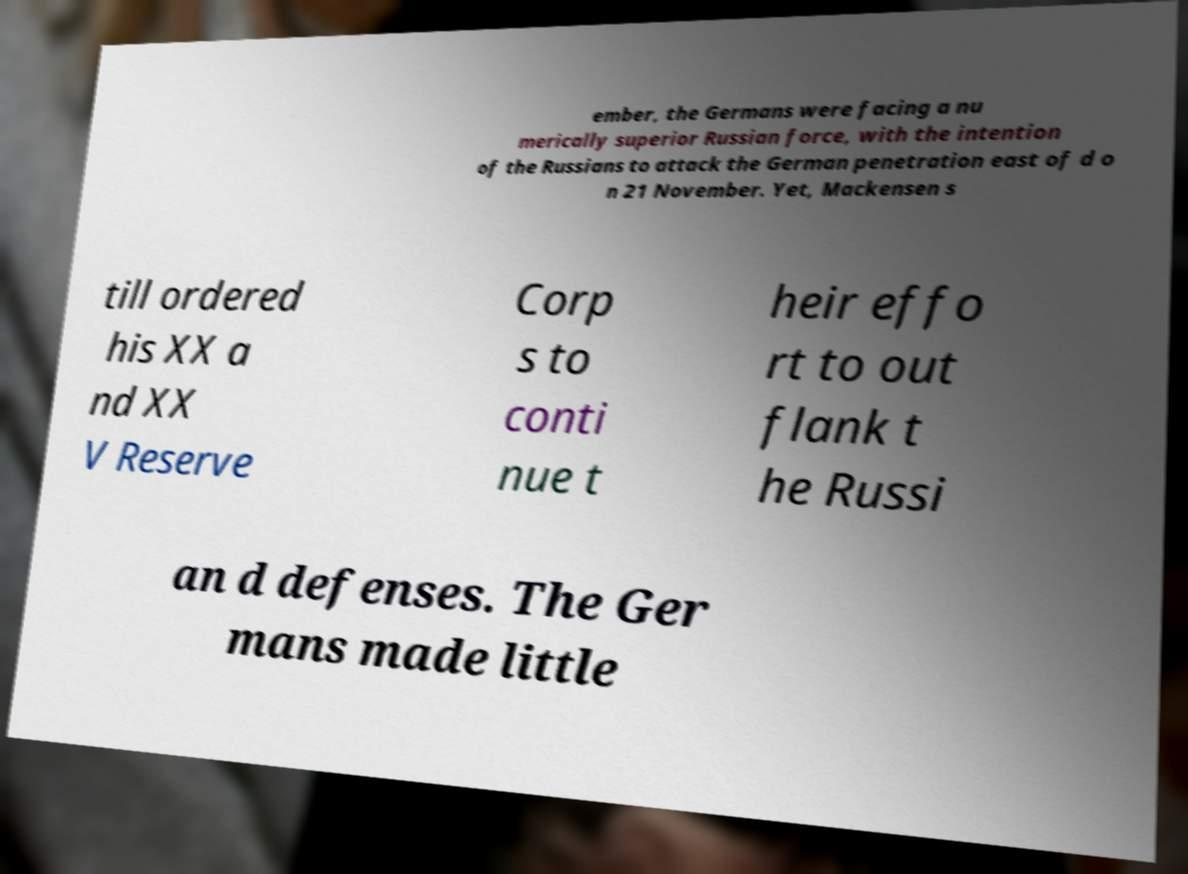I need the written content from this picture converted into text. Can you do that? ember, the Germans were facing a nu merically superior Russian force, with the intention of the Russians to attack the German penetration east of d o n 21 November. Yet, Mackensen s till ordered his XX a nd XX V Reserve Corp s to conti nue t heir effo rt to out flank t he Russi an d defenses. The Ger mans made little 